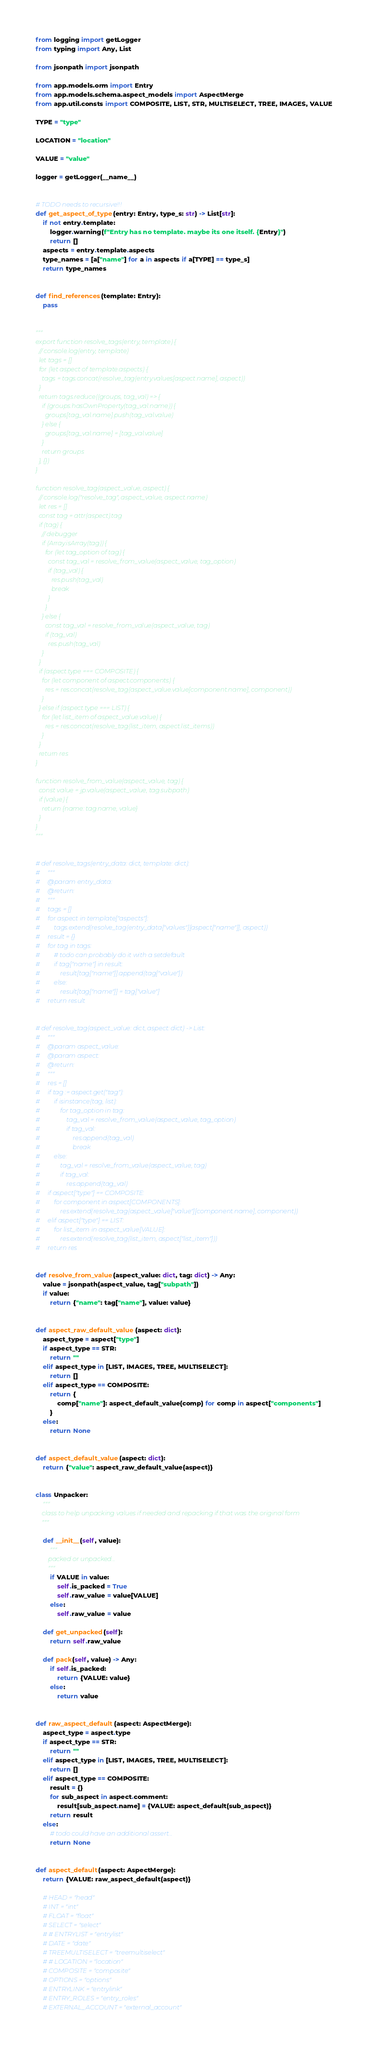<code> <loc_0><loc_0><loc_500><loc_500><_Python_>from logging import getLogger
from typing import Any, List

from jsonpath import jsonpath

from app.models.orm import Entry
from app.models.schema.aspect_models import AspectMerge
from app.util.consts import COMPOSITE, LIST, STR, MULTISELECT, TREE, IMAGES, VALUE

TYPE = "type"

LOCATION = "location"

VALUE = "value"

logger = getLogger(__name__)


# TODO needs to recursive!!!
def get_aspect_of_type(entry: Entry, type_s: str) -> List[str]:
    if not entry.template:
        logger.warning(f"Entry has no template. maybe its one itself. {Entry}")
        return []
    aspects = entry.template.aspects
    type_names = [a["name"] for a in aspects if a[TYPE] == type_s]
    return type_names


def find_references(template: Entry):
    pass


"""
export function resolve_tags(entry, template) {
  // console.log(entry, template)
  let tags = []
  for (let aspect of template.aspects) {
    tags = tags.concat(resolve_tag(entry.values[aspect.name], aspect))
  }
  return tags.reduce((groups, tag_val) => {
    if (groups.hasOwnProperty(tag_val.name)) {
      groups[tag_val.name].push(tag_val.value)
    } else {
      groups[tag_val.name] = [tag_val.value]
    }
    return groups
  }, {})
}

function resolve_tag(aspect_value, aspect) {
  // console.log("resolve_tag", aspect_value, aspect.name)
  let res = []
  const tag = attr(aspect).tag
  if (tag) {
    // debugger
    if (Array.isArray(tag)) {
      for (let tag_option of tag) {
        const tag_val = resolve_from_value(aspect_value, tag_option)
        if (tag_val) {
          res.push(tag_val)
          break
        }
      }
    } else {
      const tag_val = resolve_from_value(aspect_value, tag)
      if (tag_val)
        res.push(tag_val)
    }
  }
  if (aspect.type === COMPOSITE) {
    for (let component of aspect.components) {
      res = res.concat(resolve_tag(aspect_value.value[component.name], component))
    }
  } else if (aspect.type === LIST) {
    for (let list_item of aspect_value.value) {
      res = res.concat(resolve_tag(list_item, aspect.list_items))
    }
  }
  return res
}

function resolve_from_value(aspect_value, tag) {
  const value = jp.value(aspect_value, tag.subpath)
  if (value) {
    return {name: tag.name, value}
  }
}
"""


# def resolve_tags(entry_data: dict, template: dict):
#     """
#     @param entry_data:
#     @return:
#     """
#     tags = []
#     for aspect in template["aspects"]:
#         tags.extend(resolve_tag(entry_data["values"][aspect["name"]], aspect))
#     result = {}
#     for tag in tags:
#         # todo can probably do it with a setdefault
#         if tag["name"] in result:
#             result[tag["name"]].append(tag["value"])
#         else:
#             result[tag["name"]] = tag["value"]
#     return result


# def resolve_tag(aspect_value: dict, aspect: dict) -> List:
#     """
#     @param aspect_value:
#     @param aspect:
#     @return:
#     """
#     res = []
#     if tag := aspect.get("tag"):
#         if isinstance(tag, list):
#             for tag_option in tag:
#                 tag_val = resolve_from_value(aspect_value, tag_option)
#                 if tag_val:
#                     res.append(tag_val)
#                     break
#         else:
#             tag_val = resolve_from_value(aspect_value, tag)
#             if tag_val:
#                 res.append(tag_val)
#     if aspect["type"] == COMPOSITE:
#         for component in aspect[COMPONENTS]:
#             res.extend(resolve_tag(aspect_value["value"][component.name], component))
#     elif aspect["type"] == LIST:
#         for list_item in aspect_value[VALUE]:
#             res.extend(resolve_tag(list_item, aspect["list_item"]))
#     return res


def resolve_from_value(aspect_value: dict, tag: dict) -> Any:
    value = jsonpath(aspect_value, tag["subpath"])
    if value:
        return {"name": tag["name"], value: value}


def aspect_raw_default_value(aspect: dict):
    aspect_type = aspect["type"]
    if aspect_type == STR:
        return ""
    elif aspect_type in [LIST, IMAGES, TREE, MULTISELECT]:
        return []
    elif aspect_type == COMPOSITE:
        return {
            comp["name"]: aspect_default_value(comp) for comp in aspect["components"]
        }
    else:
        return None


def aspect_default_value(aspect: dict):
    return {"value": aspect_raw_default_value(aspect)}


class Unpacker:
    """
    class to help unpacking values if needed and repacking if that was the original form
    """

    def __init__(self, value):
        """
        packed or unpacked...
        """
        if VALUE in value:
            self.is_packed = True
            self.raw_value = value[VALUE]
        else:
            self.raw_value = value

    def get_unpacked(self):
        return self.raw_value

    def pack(self, value) -> Any:
        if self.is_packed:
            return {VALUE: value}
        else:
            return value


def raw_aspect_default(aspect: AspectMerge):
    aspect_type = aspect.type
    if aspect_type == STR:
        return ""
    elif aspect_type in [LIST, IMAGES, TREE, MULTISELECT]:
        return []
    elif aspect_type == COMPOSITE:
        result = {}
        for sub_aspect in aspect.comment:
            result[sub_aspect.name] = {VALUE: aspect_default(sub_aspect)}
        return result
    else:
        # todo could have an additional assert...
        return None


def aspect_default(aspect: AspectMerge):
    return {VALUE: raw_aspect_default(aspect)}

    # HEAD = "head"
    # INT = "int"
    # FLOAT = "float"
    # SELECT = "select"
    # # ENTRYLIST = "entrylist"
    # DATE = "date"
    # TREEMULTISELECT = "treemultiselect"
    # # LOCATION = "location"
    # COMPOSITE = "composite"
    # OPTIONS = "options"
    # ENTRYLINK = "entrylink"
    # ENTRY_ROLES = "entry_roles"
    # EXTERNAL_ACCOUNT = "external_account"</code> 